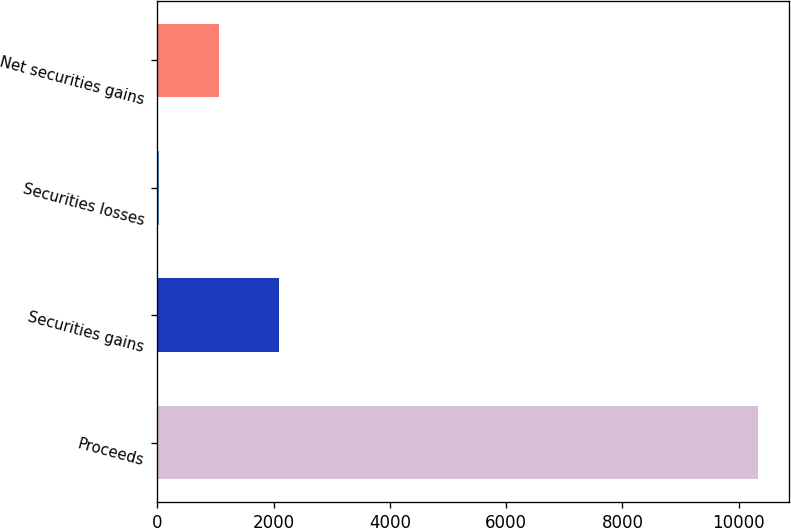Convert chart. <chart><loc_0><loc_0><loc_500><loc_500><bar_chart><fcel>Proceeds<fcel>Securities gains<fcel>Securities losses<fcel>Net securities gains<nl><fcel>10340<fcel>2092<fcel>30<fcel>1061<nl></chart> 